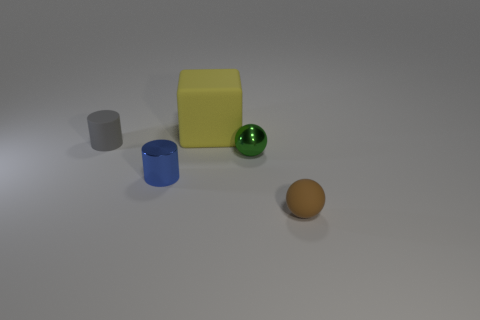Is the number of small metal objects to the right of the big rubber cube less than the number of blue metal things that are left of the matte cylinder?
Give a very brief answer. No. What is the shape of the tiny shiny object on the left side of the big yellow cube?
Give a very brief answer. Cylinder. Is the material of the gray cylinder the same as the yellow cube?
Keep it short and to the point. Yes. There is a blue thing that is the same shape as the small gray matte thing; what is its material?
Provide a succinct answer. Metal. Are there fewer big yellow cubes on the left side of the tiny blue cylinder than green rubber spheres?
Your answer should be compact. No. How many small blue things are in front of the big block?
Make the answer very short. 1. Is the shape of the matte object left of the rubber block the same as the small blue thing to the left of the tiny green metal object?
Your answer should be very brief. Yes. The small object that is both left of the small green sphere and in front of the tiny gray object has what shape?
Provide a succinct answer. Cylinder. There is a block that is the same material as the small brown thing; what size is it?
Ensure brevity in your answer.  Large. Are there fewer objects than tiny blue rubber cylinders?
Provide a short and direct response. No. 